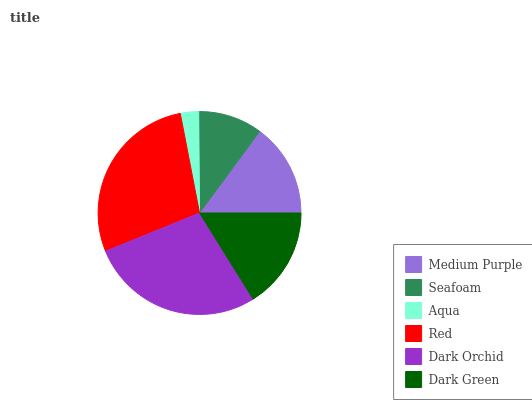Is Aqua the minimum?
Answer yes or no. Yes. Is Red the maximum?
Answer yes or no. Yes. Is Seafoam the minimum?
Answer yes or no. No. Is Seafoam the maximum?
Answer yes or no. No. Is Medium Purple greater than Seafoam?
Answer yes or no. Yes. Is Seafoam less than Medium Purple?
Answer yes or no. Yes. Is Seafoam greater than Medium Purple?
Answer yes or no. No. Is Medium Purple less than Seafoam?
Answer yes or no. No. Is Dark Green the high median?
Answer yes or no. Yes. Is Medium Purple the low median?
Answer yes or no. Yes. Is Red the high median?
Answer yes or no. No. Is Aqua the low median?
Answer yes or no. No. 